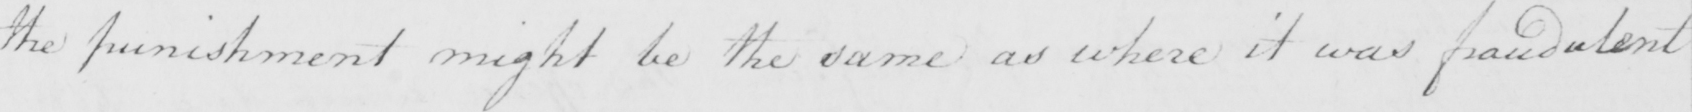What text is written in this handwritten line? the punishment might be the same as where it was fraudulent 